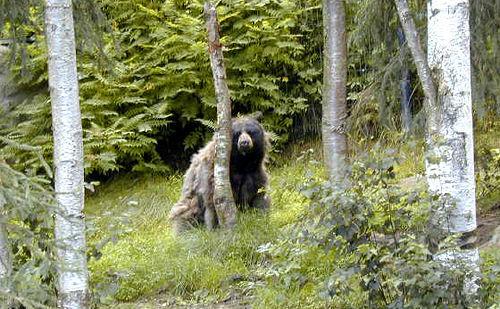What animal is in the picture?
Keep it brief. Bear. Is there lots of greenery for the bear to eat?
Answer briefly. Yes. What is wrong with the bear?
Short answer required. Hiding. 